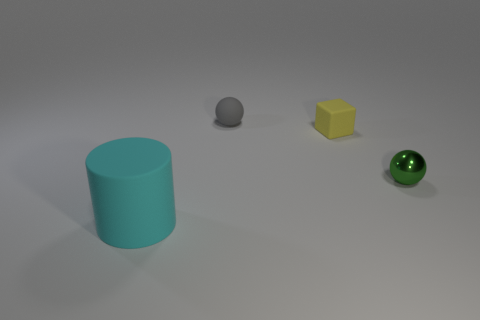Add 2 large cyan matte cylinders. How many objects exist? 6 Subtract 1 cylinders. How many cylinders are left? 0 Subtract all gray balls. How many balls are left? 1 Subtract all cylinders. How many objects are left? 3 Subtract 0 gray cubes. How many objects are left? 4 Subtract all gray spheres. Subtract all green cylinders. How many spheres are left? 1 Subtract all tiny matte things. Subtract all large cyan things. How many objects are left? 1 Add 2 balls. How many balls are left? 4 Add 4 green things. How many green things exist? 5 